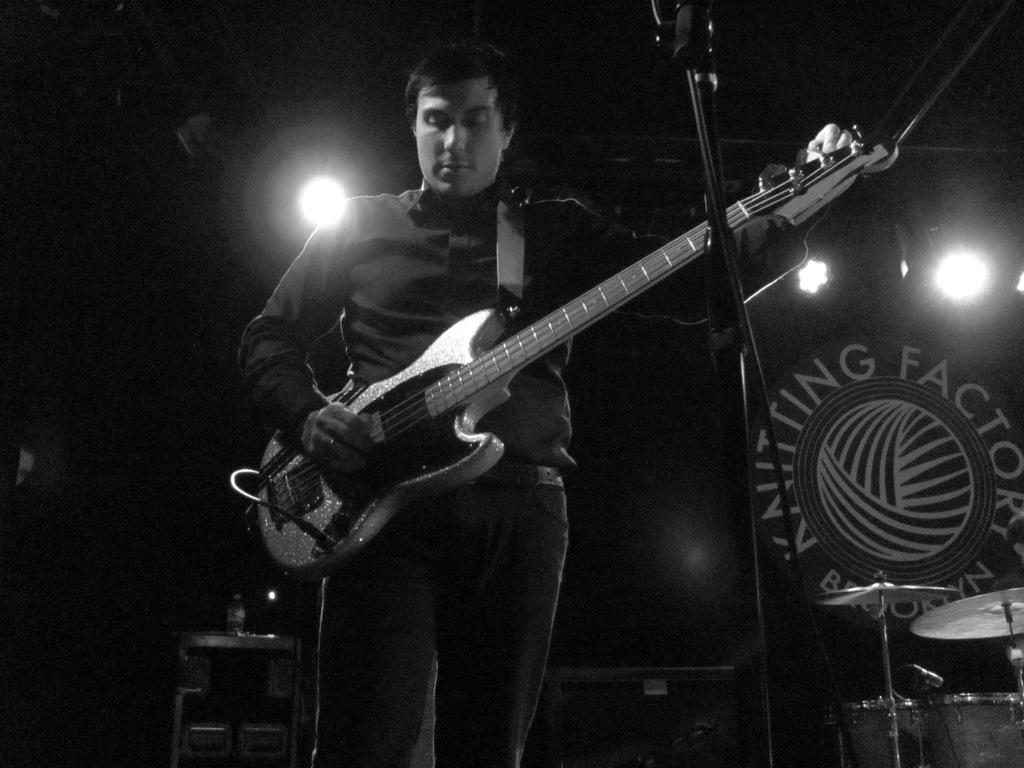What is the man in the image doing? The man is playing a guitar in the image. What musical instruments can be seen in the image? There are cymbals inals in the background of the image. What objects are present in the background of the image? There is a table, a bottle, and a focus light in the background of the image. How does the man make the payment for his performance in the image? There is no indication of payment in the image; it only shows the man playing the guitar and the surrounding objects. 